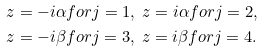<formula> <loc_0><loc_0><loc_500><loc_500>& z = - i \alpha f o r j = 1 , \ z = i \alpha f o r j = 2 , \\ & z = - i \beta f o r j = 3 , \ z = i \beta f o r j = 4 .</formula> 